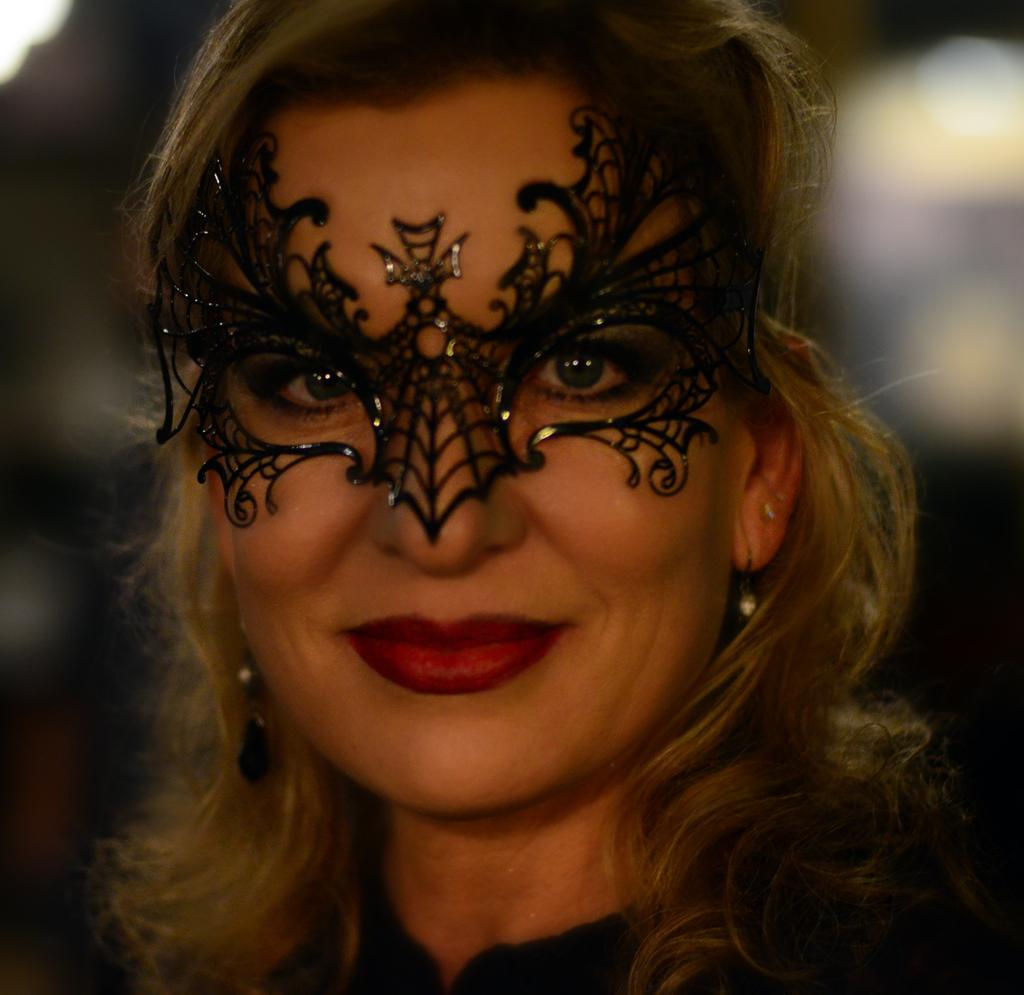Who is the main subject in the image? There is a lady in the image. What is the lady wearing on her face? The lady is wearing a mask. Can you describe the background of the image? The background of the image is blurred. What type of ink is being used by the lady in the image? There is no ink present in the image, as the lady is wearing a mask and not engaging in any activity that would involve ink. 